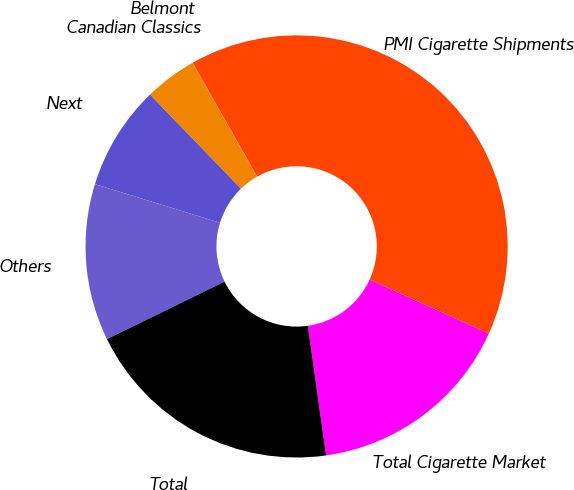Convert chart to OTSL. <chart><loc_0><loc_0><loc_500><loc_500><pie_chart><fcel>Total Cigarette Market<fcel>PMI Cigarette Shipments<fcel>Belmont<fcel>Canadian Classics<fcel>Next<fcel>Others<fcel>Total<nl><fcel>16.0%<fcel>39.97%<fcel>0.01%<fcel>4.01%<fcel>8.01%<fcel>12.0%<fcel>19.99%<nl></chart> 